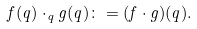Convert formula to latex. <formula><loc_0><loc_0><loc_500><loc_500>f ( q ) \cdot _ { q } g ( q ) \colon = ( f \cdot g ) ( q ) .</formula> 